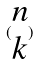Convert formula to latex. <formula><loc_0><loc_0><loc_500><loc_500>( \begin{matrix} n \\ k \end{matrix} )</formula> 